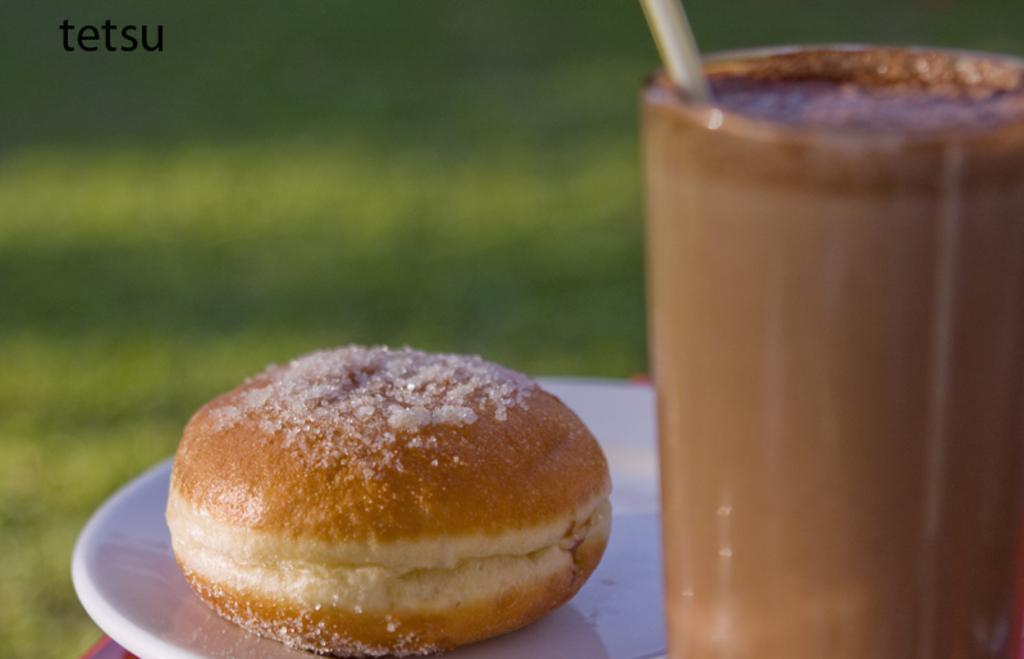Could you give a brief overview of what you see in this image? This is a zoomed in picture. On the right there is a glass of drink containing a straw which seems to be placed on the table. On the left there is a plate containing a food item seems to be placed on the top of the table. The background of the image is blur and it is green in color. At the top left corner there is a text on the image. 